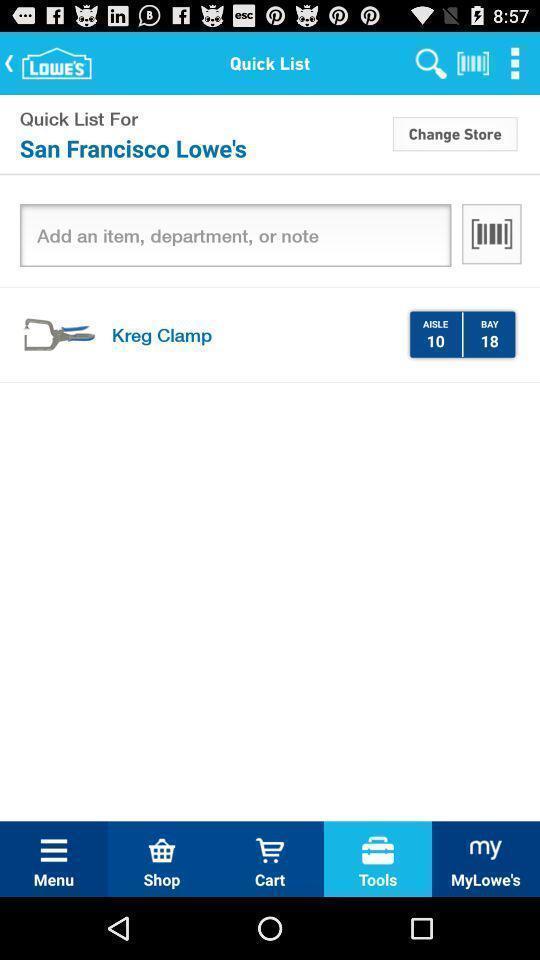Summarize the main components in this picture. Screen showing quick list with options. 